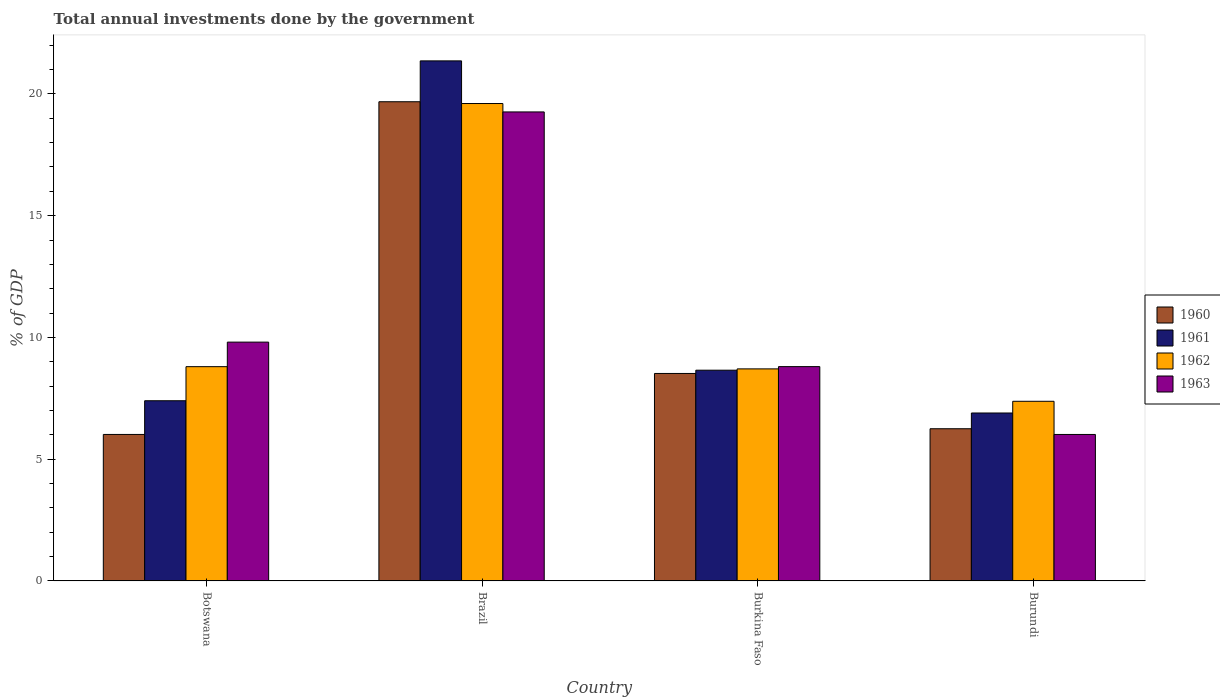How many groups of bars are there?
Your answer should be very brief. 4. Are the number of bars per tick equal to the number of legend labels?
Offer a very short reply. Yes. How many bars are there on the 2nd tick from the left?
Offer a terse response. 4. How many bars are there on the 1st tick from the right?
Provide a succinct answer. 4. What is the label of the 2nd group of bars from the left?
Your answer should be very brief. Brazil. In how many cases, is the number of bars for a given country not equal to the number of legend labels?
Provide a short and direct response. 0. What is the total annual investments done by the government in 1960 in Botswana?
Provide a short and direct response. 6.02. Across all countries, what is the maximum total annual investments done by the government in 1962?
Provide a short and direct response. 19.6. Across all countries, what is the minimum total annual investments done by the government in 1960?
Your answer should be compact. 6.02. In which country was the total annual investments done by the government in 1963 minimum?
Your answer should be very brief. Burundi. What is the total total annual investments done by the government in 1963 in the graph?
Offer a terse response. 43.88. What is the difference between the total annual investments done by the government in 1961 in Burkina Faso and that in Burundi?
Keep it short and to the point. 1.76. What is the difference between the total annual investments done by the government in 1961 in Botswana and the total annual investments done by the government in 1962 in Brazil?
Keep it short and to the point. -12.21. What is the average total annual investments done by the government in 1961 per country?
Provide a succinct answer. 11.08. What is the difference between the total annual investments done by the government of/in 1961 and total annual investments done by the government of/in 1960 in Burundi?
Your answer should be compact. 0.65. What is the ratio of the total annual investments done by the government in 1961 in Botswana to that in Burkina Faso?
Give a very brief answer. 0.86. Is the total annual investments done by the government in 1962 in Botswana less than that in Burkina Faso?
Give a very brief answer. No. What is the difference between the highest and the second highest total annual investments done by the government in 1960?
Your answer should be compact. -11.16. What is the difference between the highest and the lowest total annual investments done by the government in 1962?
Provide a succinct answer. 12.23. Is the sum of the total annual investments done by the government in 1963 in Botswana and Burundi greater than the maximum total annual investments done by the government in 1962 across all countries?
Provide a short and direct response. No. What does the 1st bar from the left in Burkina Faso represents?
Give a very brief answer. 1960. What does the 4th bar from the right in Burundi represents?
Ensure brevity in your answer.  1960. Is it the case that in every country, the sum of the total annual investments done by the government in 1963 and total annual investments done by the government in 1960 is greater than the total annual investments done by the government in 1961?
Make the answer very short. Yes. How many bars are there?
Provide a succinct answer. 16. Are all the bars in the graph horizontal?
Your response must be concise. No. Are the values on the major ticks of Y-axis written in scientific E-notation?
Your answer should be compact. No. How many legend labels are there?
Offer a terse response. 4. What is the title of the graph?
Ensure brevity in your answer.  Total annual investments done by the government. Does "2012" appear as one of the legend labels in the graph?
Keep it short and to the point. No. What is the label or title of the Y-axis?
Ensure brevity in your answer.  % of GDP. What is the % of GDP of 1960 in Botswana?
Your answer should be compact. 6.02. What is the % of GDP in 1961 in Botswana?
Keep it short and to the point. 7.4. What is the % of GDP of 1962 in Botswana?
Provide a short and direct response. 8.8. What is the % of GDP in 1963 in Botswana?
Make the answer very short. 9.81. What is the % of GDP in 1960 in Brazil?
Your response must be concise. 19.68. What is the % of GDP in 1961 in Brazil?
Your answer should be compact. 21.36. What is the % of GDP of 1962 in Brazil?
Make the answer very short. 19.6. What is the % of GDP in 1963 in Brazil?
Keep it short and to the point. 19.26. What is the % of GDP in 1960 in Burkina Faso?
Give a very brief answer. 8.52. What is the % of GDP in 1961 in Burkina Faso?
Your answer should be compact. 8.65. What is the % of GDP in 1962 in Burkina Faso?
Your answer should be compact. 8.71. What is the % of GDP in 1963 in Burkina Faso?
Make the answer very short. 8.8. What is the % of GDP in 1960 in Burundi?
Provide a succinct answer. 6.25. What is the % of GDP in 1961 in Burundi?
Offer a very short reply. 6.9. What is the % of GDP of 1962 in Burundi?
Your response must be concise. 7.38. What is the % of GDP in 1963 in Burundi?
Offer a very short reply. 6.02. Across all countries, what is the maximum % of GDP of 1960?
Provide a succinct answer. 19.68. Across all countries, what is the maximum % of GDP in 1961?
Your response must be concise. 21.36. Across all countries, what is the maximum % of GDP in 1962?
Your answer should be compact. 19.6. Across all countries, what is the maximum % of GDP in 1963?
Provide a succinct answer. 19.26. Across all countries, what is the minimum % of GDP of 1960?
Offer a very short reply. 6.02. Across all countries, what is the minimum % of GDP of 1961?
Ensure brevity in your answer.  6.9. Across all countries, what is the minimum % of GDP of 1962?
Provide a short and direct response. 7.38. Across all countries, what is the minimum % of GDP in 1963?
Your answer should be compact. 6.02. What is the total % of GDP of 1960 in the graph?
Provide a short and direct response. 40.46. What is the total % of GDP in 1961 in the graph?
Provide a short and direct response. 44.31. What is the total % of GDP in 1962 in the graph?
Your response must be concise. 44.49. What is the total % of GDP in 1963 in the graph?
Ensure brevity in your answer.  43.88. What is the difference between the % of GDP in 1960 in Botswana and that in Brazil?
Give a very brief answer. -13.66. What is the difference between the % of GDP in 1961 in Botswana and that in Brazil?
Make the answer very short. -13.96. What is the difference between the % of GDP in 1962 in Botswana and that in Brazil?
Your response must be concise. -10.81. What is the difference between the % of GDP of 1963 in Botswana and that in Brazil?
Your answer should be very brief. -9.45. What is the difference between the % of GDP of 1960 in Botswana and that in Burkina Faso?
Ensure brevity in your answer.  -2.5. What is the difference between the % of GDP in 1961 in Botswana and that in Burkina Faso?
Offer a very short reply. -1.25. What is the difference between the % of GDP in 1962 in Botswana and that in Burkina Faso?
Offer a terse response. 0.09. What is the difference between the % of GDP in 1963 in Botswana and that in Burkina Faso?
Your answer should be compact. 1.01. What is the difference between the % of GDP in 1960 in Botswana and that in Burundi?
Keep it short and to the point. -0.23. What is the difference between the % of GDP of 1961 in Botswana and that in Burundi?
Keep it short and to the point. 0.5. What is the difference between the % of GDP of 1962 in Botswana and that in Burundi?
Ensure brevity in your answer.  1.42. What is the difference between the % of GDP of 1963 in Botswana and that in Burundi?
Offer a terse response. 3.79. What is the difference between the % of GDP in 1960 in Brazil and that in Burkina Faso?
Offer a very short reply. 11.16. What is the difference between the % of GDP in 1961 in Brazil and that in Burkina Faso?
Provide a succinct answer. 12.7. What is the difference between the % of GDP of 1962 in Brazil and that in Burkina Faso?
Keep it short and to the point. 10.9. What is the difference between the % of GDP in 1963 in Brazil and that in Burkina Faso?
Your answer should be very brief. 10.46. What is the difference between the % of GDP in 1960 in Brazil and that in Burundi?
Make the answer very short. 13.43. What is the difference between the % of GDP of 1961 in Brazil and that in Burundi?
Make the answer very short. 14.46. What is the difference between the % of GDP of 1962 in Brazil and that in Burundi?
Give a very brief answer. 12.23. What is the difference between the % of GDP in 1963 in Brazil and that in Burundi?
Provide a succinct answer. 13.24. What is the difference between the % of GDP of 1960 in Burkina Faso and that in Burundi?
Offer a terse response. 2.27. What is the difference between the % of GDP in 1961 in Burkina Faso and that in Burundi?
Your answer should be very brief. 1.76. What is the difference between the % of GDP in 1962 in Burkina Faso and that in Burundi?
Give a very brief answer. 1.33. What is the difference between the % of GDP of 1963 in Burkina Faso and that in Burundi?
Provide a short and direct response. 2.79. What is the difference between the % of GDP of 1960 in Botswana and the % of GDP of 1961 in Brazil?
Provide a succinct answer. -15.34. What is the difference between the % of GDP in 1960 in Botswana and the % of GDP in 1962 in Brazil?
Keep it short and to the point. -13.59. What is the difference between the % of GDP of 1960 in Botswana and the % of GDP of 1963 in Brazil?
Keep it short and to the point. -13.24. What is the difference between the % of GDP of 1961 in Botswana and the % of GDP of 1962 in Brazil?
Offer a terse response. -12.21. What is the difference between the % of GDP of 1961 in Botswana and the % of GDP of 1963 in Brazil?
Provide a succinct answer. -11.86. What is the difference between the % of GDP in 1962 in Botswana and the % of GDP in 1963 in Brazil?
Your response must be concise. -10.46. What is the difference between the % of GDP of 1960 in Botswana and the % of GDP of 1961 in Burkina Faso?
Your answer should be very brief. -2.64. What is the difference between the % of GDP of 1960 in Botswana and the % of GDP of 1962 in Burkina Faso?
Make the answer very short. -2.69. What is the difference between the % of GDP of 1960 in Botswana and the % of GDP of 1963 in Burkina Faso?
Offer a terse response. -2.79. What is the difference between the % of GDP of 1961 in Botswana and the % of GDP of 1962 in Burkina Faso?
Offer a terse response. -1.31. What is the difference between the % of GDP in 1961 in Botswana and the % of GDP in 1963 in Burkina Faso?
Ensure brevity in your answer.  -1.4. What is the difference between the % of GDP in 1962 in Botswana and the % of GDP in 1963 in Burkina Faso?
Offer a terse response. -0. What is the difference between the % of GDP of 1960 in Botswana and the % of GDP of 1961 in Burundi?
Keep it short and to the point. -0.88. What is the difference between the % of GDP in 1960 in Botswana and the % of GDP in 1962 in Burundi?
Offer a very short reply. -1.36. What is the difference between the % of GDP of 1960 in Botswana and the % of GDP of 1963 in Burundi?
Make the answer very short. 0. What is the difference between the % of GDP in 1961 in Botswana and the % of GDP in 1962 in Burundi?
Your response must be concise. 0.02. What is the difference between the % of GDP in 1961 in Botswana and the % of GDP in 1963 in Burundi?
Make the answer very short. 1.38. What is the difference between the % of GDP of 1962 in Botswana and the % of GDP of 1963 in Burundi?
Your response must be concise. 2.78. What is the difference between the % of GDP in 1960 in Brazil and the % of GDP in 1961 in Burkina Faso?
Keep it short and to the point. 11.02. What is the difference between the % of GDP of 1960 in Brazil and the % of GDP of 1962 in Burkina Faso?
Your response must be concise. 10.97. What is the difference between the % of GDP in 1960 in Brazil and the % of GDP in 1963 in Burkina Faso?
Your answer should be very brief. 10.88. What is the difference between the % of GDP of 1961 in Brazil and the % of GDP of 1962 in Burkina Faso?
Your response must be concise. 12.65. What is the difference between the % of GDP of 1961 in Brazil and the % of GDP of 1963 in Burkina Faso?
Keep it short and to the point. 12.55. What is the difference between the % of GDP in 1962 in Brazil and the % of GDP in 1963 in Burkina Faso?
Offer a terse response. 10.8. What is the difference between the % of GDP of 1960 in Brazil and the % of GDP of 1961 in Burundi?
Ensure brevity in your answer.  12.78. What is the difference between the % of GDP of 1960 in Brazil and the % of GDP of 1962 in Burundi?
Offer a very short reply. 12.3. What is the difference between the % of GDP of 1960 in Brazil and the % of GDP of 1963 in Burundi?
Offer a very short reply. 13.66. What is the difference between the % of GDP in 1961 in Brazil and the % of GDP in 1962 in Burundi?
Ensure brevity in your answer.  13.98. What is the difference between the % of GDP in 1961 in Brazil and the % of GDP in 1963 in Burundi?
Your answer should be very brief. 15.34. What is the difference between the % of GDP of 1962 in Brazil and the % of GDP of 1963 in Burundi?
Provide a succinct answer. 13.59. What is the difference between the % of GDP in 1960 in Burkina Faso and the % of GDP in 1961 in Burundi?
Offer a very short reply. 1.62. What is the difference between the % of GDP in 1960 in Burkina Faso and the % of GDP in 1962 in Burundi?
Ensure brevity in your answer.  1.14. What is the difference between the % of GDP of 1960 in Burkina Faso and the % of GDP of 1963 in Burundi?
Make the answer very short. 2.5. What is the difference between the % of GDP of 1961 in Burkina Faso and the % of GDP of 1962 in Burundi?
Ensure brevity in your answer.  1.28. What is the difference between the % of GDP in 1961 in Burkina Faso and the % of GDP in 1963 in Burundi?
Make the answer very short. 2.64. What is the difference between the % of GDP of 1962 in Burkina Faso and the % of GDP of 1963 in Burundi?
Your response must be concise. 2.69. What is the average % of GDP in 1960 per country?
Keep it short and to the point. 10.12. What is the average % of GDP of 1961 per country?
Make the answer very short. 11.08. What is the average % of GDP in 1962 per country?
Provide a short and direct response. 11.12. What is the average % of GDP in 1963 per country?
Provide a succinct answer. 10.97. What is the difference between the % of GDP in 1960 and % of GDP in 1961 in Botswana?
Your answer should be very brief. -1.38. What is the difference between the % of GDP in 1960 and % of GDP in 1962 in Botswana?
Keep it short and to the point. -2.78. What is the difference between the % of GDP of 1960 and % of GDP of 1963 in Botswana?
Provide a succinct answer. -3.79. What is the difference between the % of GDP of 1961 and % of GDP of 1962 in Botswana?
Your answer should be very brief. -1.4. What is the difference between the % of GDP of 1961 and % of GDP of 1963 in Botswana?
Your answer should be very brief. -2.41. What is the difference between the % of GDP in 1962 and % of GDP in 1963 in Botswana?
Give a very brief answer. -1.01. What is the difference between the % of GDP of 1960 and % of GDP of 1961 in Brazil?
Keep it short and to the point. -1.68. What is the difference between the % of GDP of 1960 and % of GDP of 1962 in Brazil?
Provide a succinct answer. 0.07. What is the difference between the % of GDP of 1960 and % of GDP of 1963 in Brazil?
Your response must be concise. 0.42. What is the difference between the % of GDP of 1961 and % of GDP of 1962 in Brazil?
Ensure brevity in your answer.  1.75. What is the difference between the % of GDP in 1961 and % of GDP in 1963 in Brazil?
Make the answer very short. 2.1. What is the difference between the % of GDP in 1962 and % of GDP in 1963 in Brazil?
Make the answer very short. 0.34. What is the difference between the % of GDP in 1960 and % of GDP in 1961 in Burkina Faso?
Give a very brief answer. -0.13. What is the difference between the % of GDP in 1960 and % of GDP in 1962 in Burkina Faso?
Keep it short and to the point. -0.19. What is the difference between the % of GDP of 1960 and % of GDP of 1963 in Burkina Faso?
Offer a very short reply. -0.28. What is the difference between the % of GDP of 1961 and % of GDP of 1962 in Burkina Faso?
Provide a short and direct response. -0.05. What is the difference between the % of GDP in 1961 and % of GDP in 1963 in Burkina Faso?
Give a very brief answer. -0.15. What is the difference between the % of GDP in 1962 and % of GDP in 1963 in Burkina Faso?
Offer a very short reply. -0.09. What is the difference between the % of GDP in 1960 and % of GDP in 1961 in Burundi?
Your answer should be compact. -0.65. What is the difference between the % of GDP in 1960 and % of GDP in 1962 in Burundi?
Make the answer very short. -1.13. What is the difference between the % of GDP in 1960 and % of GDP in 1963 in Burundi?
Offer a terse response. 0.23. What is the difference between the % of GDP in 1961 and % of GDP in 1962 in Burundi?
Give a very brief answer. -0.48. What is the difference between the % of GDP in 1961 and % of GDP in 1963 in Burundi?
Ensure brevity in your answer.  0.88. What is the difference between the % of GDP of 1962 and % of GDP of 1963 in Burundi?
Your answer should be compact. 1.36. What is the ratio of the % of GDP of 1960 in Botswana to that in Brazil?
Provide a short and direct response. 0.31. What is the ratio of the % of GDP in 1961 in Botswana to that in Brazil?
Ensure brevity in your answer.  0.35. What is the ratio of the % of GDP of 1962 in Botswana to that in Brazil?
Offer a terse response. 0.45. What is the ratio of the % of GDP of 1963 in Botswana to that in Brazil?
Offer a terse response. 0.51. What is the ratio of the % of GDP of 1960 in Botswana to that in Burkina Faso?
Your response must be concise. 0.71. What is the ratio of the % of GDP in 1961 in Botswana to that in Burkina Faso?
Offer a very short reply. 0.85. What is the ratio of the % of GDP of 1962 in Botswana to that in Burkina Faso?
Provide a succinct answer. 1.01. What is the ratio of the % of GDP in 1963 in Botswana to that in Burkina Faso?
Offer a very short reply. 1.11. What is the ratio of the % of GDP of 1960 in Botswana to that in Burundi?
Provide a short and direct response. 0.96. What is the ratio of the % of GDP of 1961 in Botswana to that in Burundi?
Your answer should be compact. 1.07. What is the ratio of the % of GDP of 1962 in Botswana to that in Burundi?
Give a very brief answer. 1.19. What is the ratio of the % of GDP of 1963 in Botswana to that in Burundi?
Provide a short and direct response. 1.63. What is the ratio of the % of GDP of 1960 in Brazil to that in Burkina Faso?
Make the answer very short. 2.31. What is the ratio of the % of GDP in 1961 in Brazil to that in Burkina Faso?
Keep it short and to the point. 2.47. What is the ratio of the % of GDP of 1962 in Brazil to that in Burkina Faso?
Provide a succinct answer. 2.25. What is the ratio of the % of GDP of 1963 in Brazil to that in Burkina Faso?
Make the answer very short. 2.19. What is the ratio of the % of GDP in 1960 in Brazil to that in Burundi?
Offer a terse response. 3.15. What is the ratio of the % of GDP of 1961 in Brazil to that in Burundi?
Your response must be concise. 3.1. What is the ratio of the % of GDP in 1962 in Brazil to that in Burundi?
Provide a succinct answer. 2.66. What is the ratio of the % of GDP in 1963 in Brazil to that in Burundi?
Ensure brevity in your answer.  3.2. What is the ratio of the % of GDP in 1960 in Burkina Faso to that in Burundi?
Provide a succinct answer. 1.36. What is the ratio of the % of GDP in 1961 in Burkina Faso to that in Burundi?
Ensure brevity in your answer.  1.25. What is the ratio of the % of GDP of 1962 in Burkina Faso to that in Burundi?
Your answer should be compact. 1.18. What is the ratio of the % of GDP in 1963 in Burkina Faso to that in Burundi?
Your response must be concise. 1.46. What is the difference between the highest and the second highest % of GDP in 1960?
Provide a succinct answer. 11.16. What is the difference between the highest and the second highest % of GDP of 1961?
Your answer should be compact. 12.7. What is the difference between the highest and the second highest % of GDP of 1962?
Offer a terse response. 10.81. What is the difference between the highest and the second highest % of GDP in 1963?
Keep it short and to the point. 9.45. What is the difference between the highest and the lowest % of GDP of 1960?
Provide a succinct answer. 13.66. What is the difference between the highest and the lowest % of GDP of 1961?
Provide a short and direct response. 14.46. What is the difference between the highest and the lowest % of GDP in 1962?
Your answer should be compact. 12.23. What is the difference between the highest and the lowest % of GDP of 1963?
Your answer should be very brief. 13.24. 